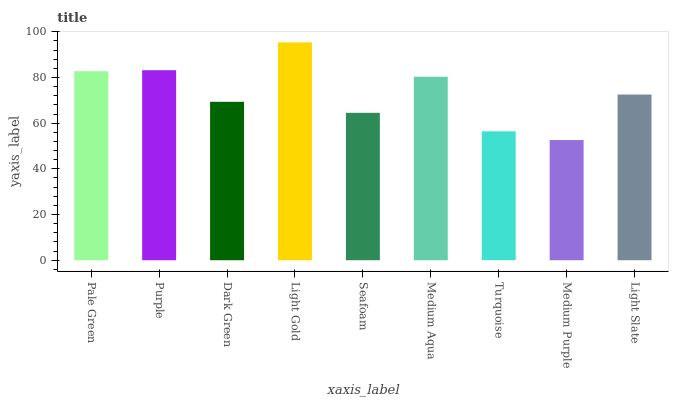Is Medium Purple the minimum?
Answer yes or no. Yes. Is Light Gold the maximum?
Answer yes or no. Yes. Is Purple the minimum?
Answer yes or no. No. Is Purple the maximum?
Answer yes or no. No. Is Purple greater than Pale Green?
Answer yes or no. Yes. Is Pale Green less than Purple?
Answer yes or no. Yes. Is Pale Green greater than Purple?
Answer yes or no. No. Is Purple less than Pale Green?
Answer yes or no. No. Is Light Slate the high median?
Answer yes or no. Yes. Is Light Slate the low median?
Answer yes or no. Yes. Is Medium Aqua the high median?
Answer yes or no. No. Is Light Gold the low median?
Answer yes or no. No. 